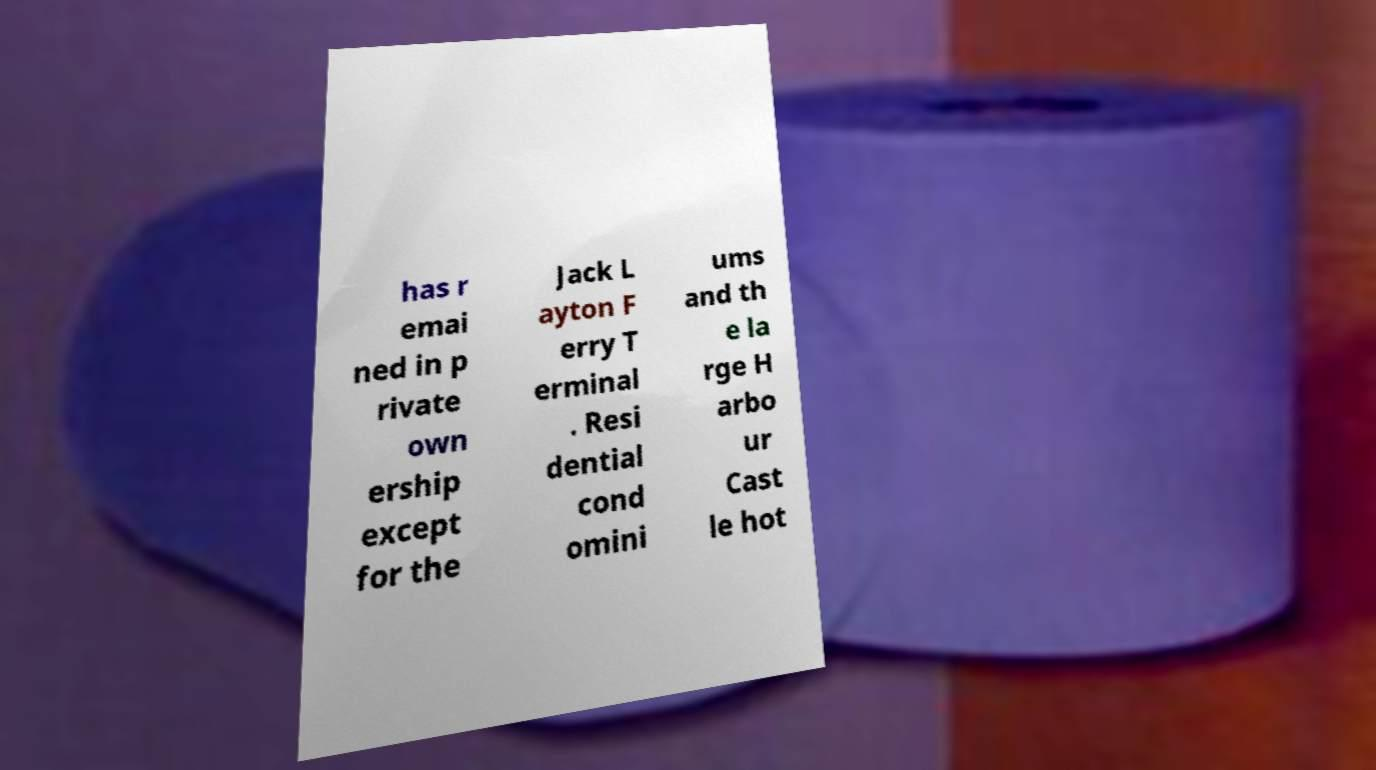Please identify and transcribe the text found in this image. has r emai ned in p rivate own ership except for the Jack L ayton F erry T erminal . Resi dential cond omini ums and th e la rge H arbo ur Cast le hot 